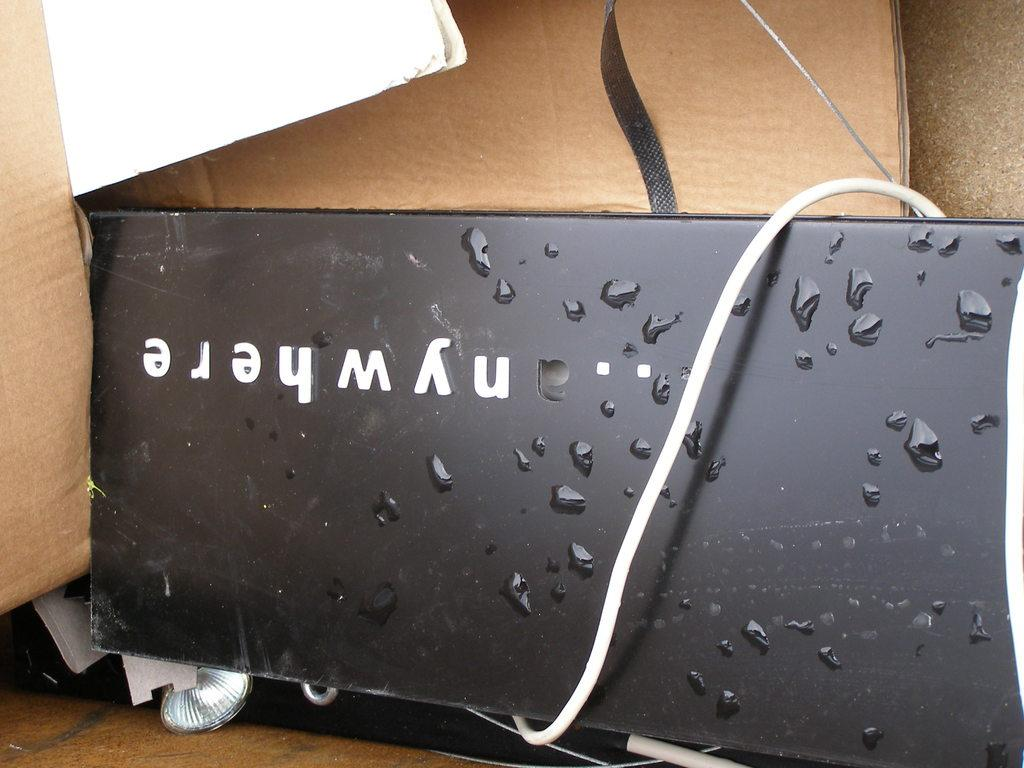<image>
Write a terse but informative summary of the picture. A black phone that is upside down and has the letters nywhere on it 